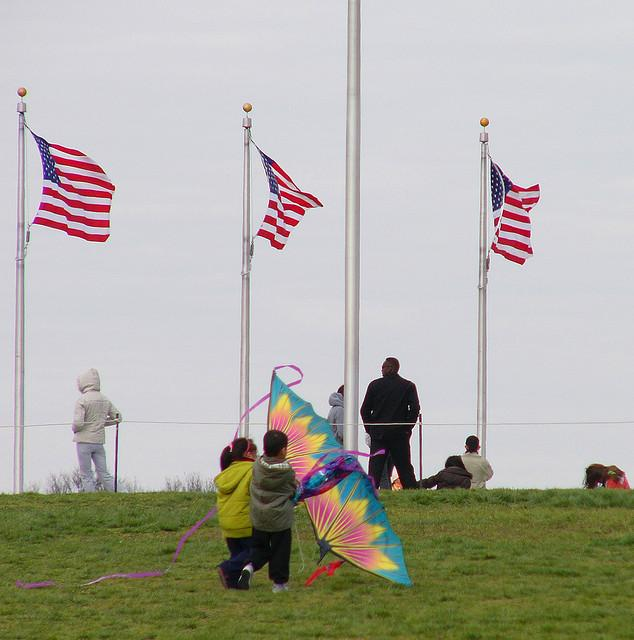What are the silver poles being used for?

Choices:
A) flying flags
B) climbing
C) flinging
D) swinging flying flags 